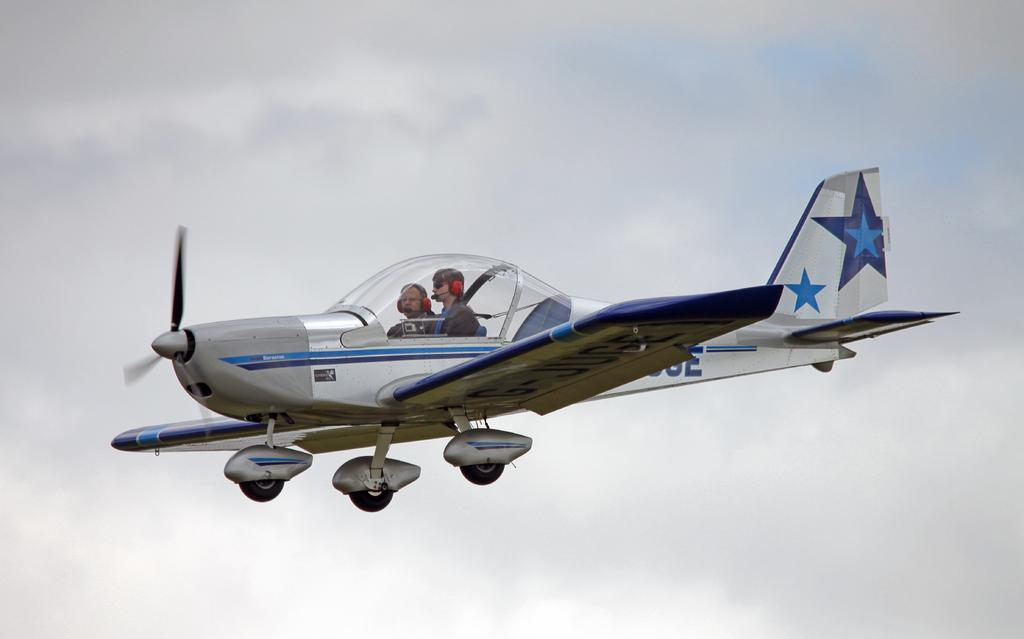What is the main subject of the image? The main subject of the image is an airplane. How many people are visible inside the airplane? There are two people sitting in the airplane. What colors are used to paint the airplane? The airplane is in white and grey color. What is visible at the top of the image? The sky is visible at the top of the image. How many gold hearts can be seen on the beds in the image? There are no beds or gold hearts present in the image; it features an airplane with two people inside. 